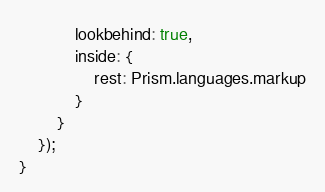<code> <loc_0><loc_0><loc_500><loc_500><_JavaScript_>			lookbehind: true,
			inside: {
				rest: Prism.languages.markup
			}
		}
	});
}</code> 